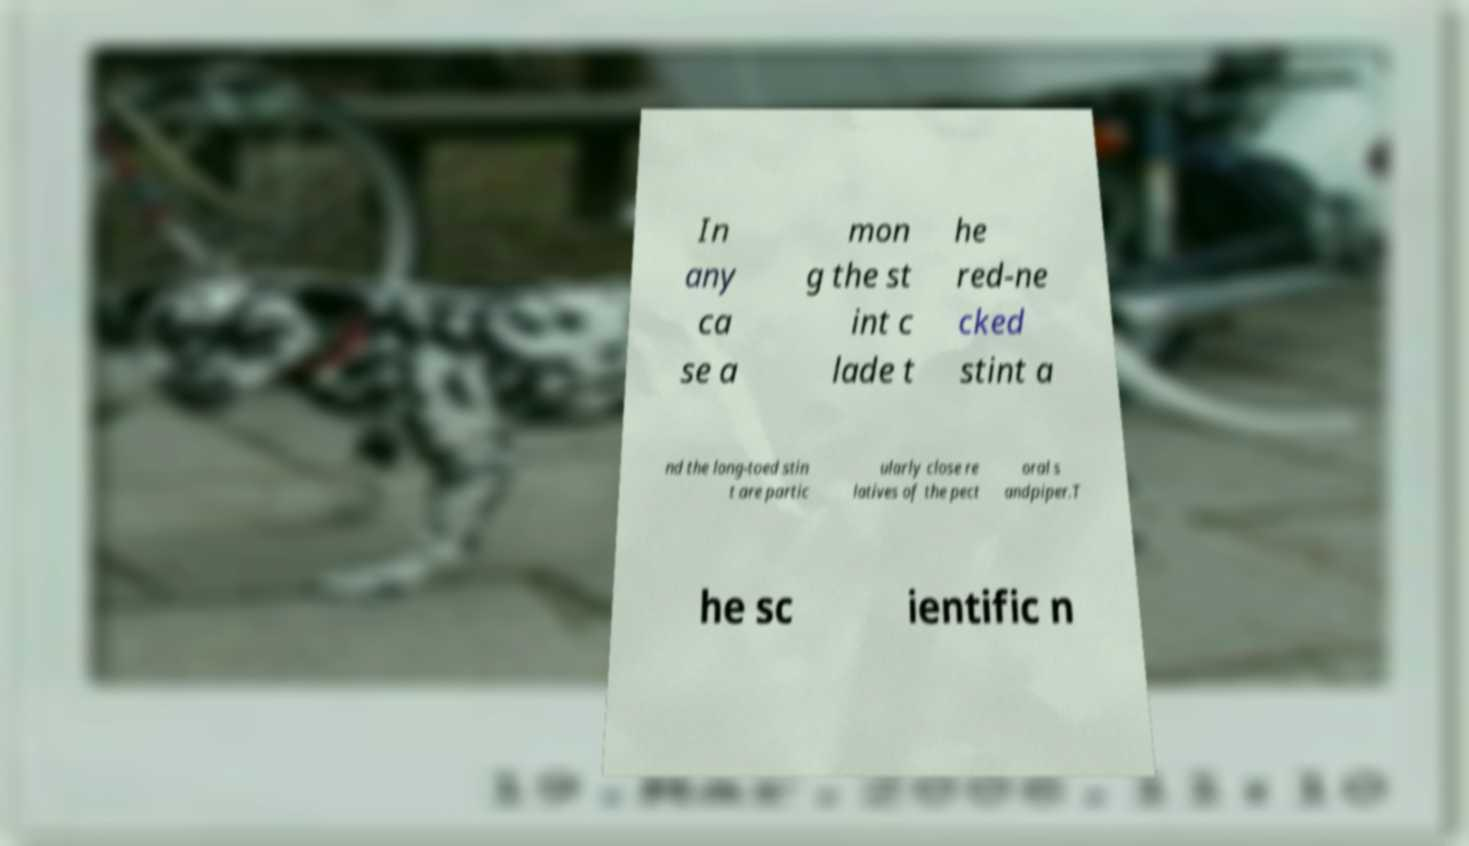There's text embedded in this image that I need extracted. Can you transcribe it verbatim? In any ca se a mon g the st int c lade t he red-ne cked stint a nd the long-toed stin t are partic ularly close re latives of the pect oral s andpiper.T he sc ientific n 